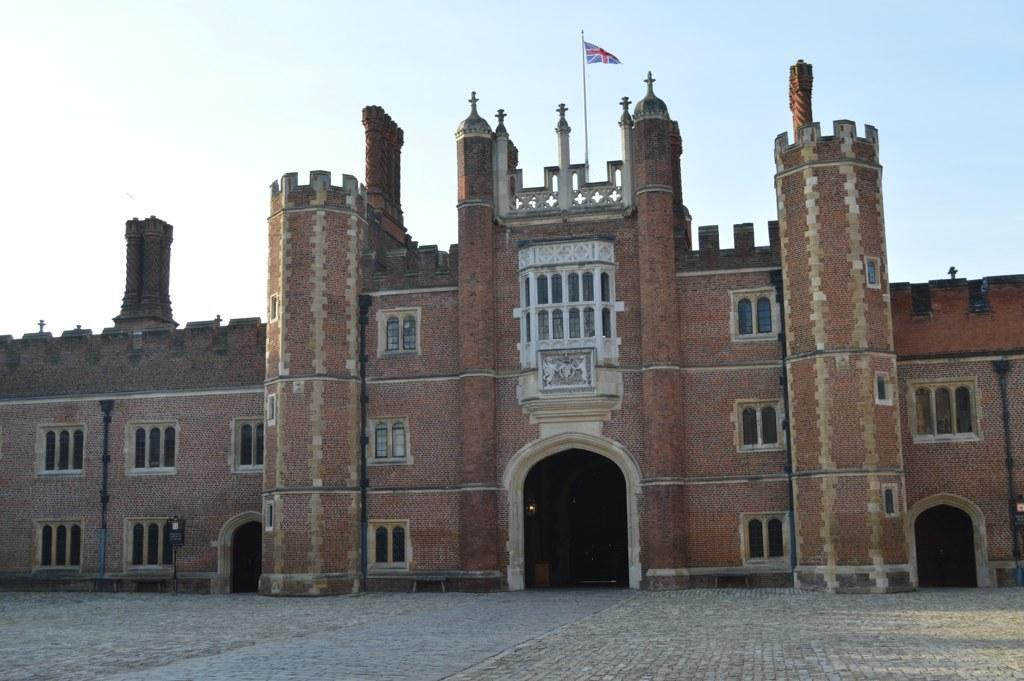What is the main subject of the image? The main subject of the image is a building. What is on top of the building? There is a flag on top of the building. What can be seen in the background of the image? The sky is visible in the background of the image. How many teeth can be seen on the building in the image? There are no teeth visible on the building in the image. What type of weather is occurring during the rainstorm in the image? There is no rainstorm present in the image; it only shows a building with a flag and the sky in the background. 